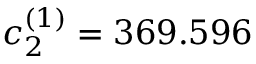Convert formula to latex. <formula><loc_0><loc_0><loc_500><loc_500>c _ { 2 } ^ { ( 1 ) } = 3 6 9 . 5 9 6</formula> 